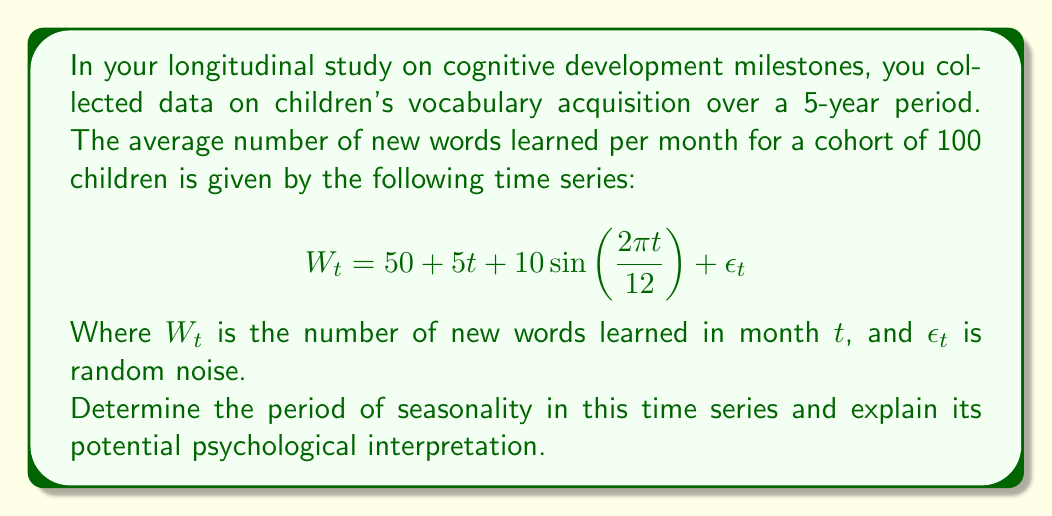Teach me how to tackle this problem. To determine the seasonality in this longitudinal data of cognitive development milestones, we need to analyze the components of the given time series equation:

$$ W_t = 50 + 5t + 10\sin\left(\frac{2\pi t}{12}\right) + \epsilon_t $$

1. The constant term 50 represents the baseline number of new words learned per month.

2. The term $5t$ represents a linear trend, indicating that children tend to learn 5 more words each month as they grow older.

3. The sine function $10\sin\left(\frac{2\pi t}{12}\right)$ represents the seasonal component:
   - The amplitude of the seasonal effect is 10 words.
   - The argument of the sine function is $\frac{2\pi t}{12}$.

4. $\epsilon_t$ represents random fluctuations or noise in the data.

To find the period of seasonality, we need to determine when the sine function completes one full cycle. This occurs when:

$$ \frac{2\pi t}{12} = 2\pi $$

Solving for $t$:

$$ t = 12 $$

This means the seasonal pattern repeats every 12 months, indicating an annual cycle in vocabulary acquisition.

Psychological interpretation:
As a psychologist, you might interpret this annual cycle in several ways:

1. School year effect: Children may learn more words during the school year and fewer during summer breaks.

2. Seasonal activities: Different seasons might expose children to different vocabularies (e.g., winter sports terms in winter, nature-related words in spring).

3. Cognitive development cycles: There might be natural annual rhythms in children's cognitive development that affect their ability to acquire new words.

4. Parental interaction patterns: Parents' engagement with their children might vary seasonally, affecting vocabulary exposure and learning.

This seasonality provides valuable insights into the complex interplay between environmental factors, educational structures, and cognitive development in children's language acquisition.
Answer: The period of seasonality in the given time series is 12 months. This indicates an annual cycle in children's vocabulary acquisition, which could be attributed to factors such as the school year effect, seasonal activities, cognitive development cycles, or seasonal patterns in parental interaction. 